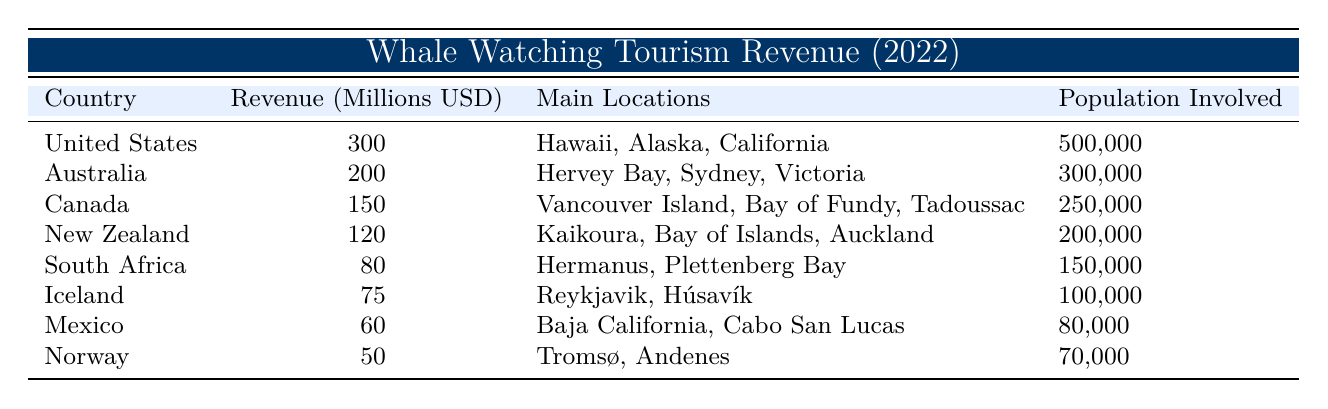What country generated the highest whale watching tourism revenue in 2022? Referring to the table, the United States is listed with a revenue of 300 million USD, which is higher than any other country in the data.
Answer: United States What is the total whale watching tourism revenue from Australia and Canada? According to the table, Australia generated 200 million USD and Canada generated 150 million USD. Therefore, the total revenue is 200 + 150 = 350 million USD.
Answer: 350 million USD Which country had the lowest whale watching tourism revenue, and what was the value? The table shows that Norway had the lowest revenue at 50 million USD when compared to the other countries.
Answer: Norway, 50 million USD Is it true that Iceland generated more than 70 million USD in whale watching tourism revenue? The data indicates Iceland generated 75 million USD, which is indeed more than 70 million USD.
Answer: Yes How many countries had a revenue greater than 100 million USD? Upon checking the table, the countries that exceeded 100 million USD are the United States (300), Australia (200), and Canada (150). Thus, there are three countries.
Answer: 3 What is the average revenue of the countries listed in the table? To calculate the average, sum the revenues: 300 + 200 + 150 + 120 + 80 + 75 + 60 + 50 = 1035 million USD. There are 8 countries, so the average is 1035 / 8 = 129.375 million USD.
Answer: 129.375 million USD Which country had the most significant difference in revenue compared to the country with the second-highest revenue? The United States had 300 million USD, and Australia had the second-highest at 200 million USD. The difference is 300 - 200 = 100 million USD, which is the largest difference.
Answer: 100 million USD If we consider only the populations involved, which country has the highest population engaged in whale watching tourism? The United States has 500,000 people involved, which is greater than the populations of all other countries listed.
Answer: United States What is the total population involved in whale watching tourism across all countries in the table? The populations involved are: 500,000 (US) + 300,000 (Australia) + 250,000 (Canada) + 200,000 (New Zealand) + 150,000 (South Africa) + 100,000 (Iceland) + 80,000 (Mexico) + 70,000 (Norway) = 1,650,000.
Answer: 1,650,000 Which country’s revenue is closest to the average revenue of all countries? The average revenue calculated was 129.375 million USD. New Zealand, with a revenue of 120 million USD, is closest to this average.
Answer: New Zealand 